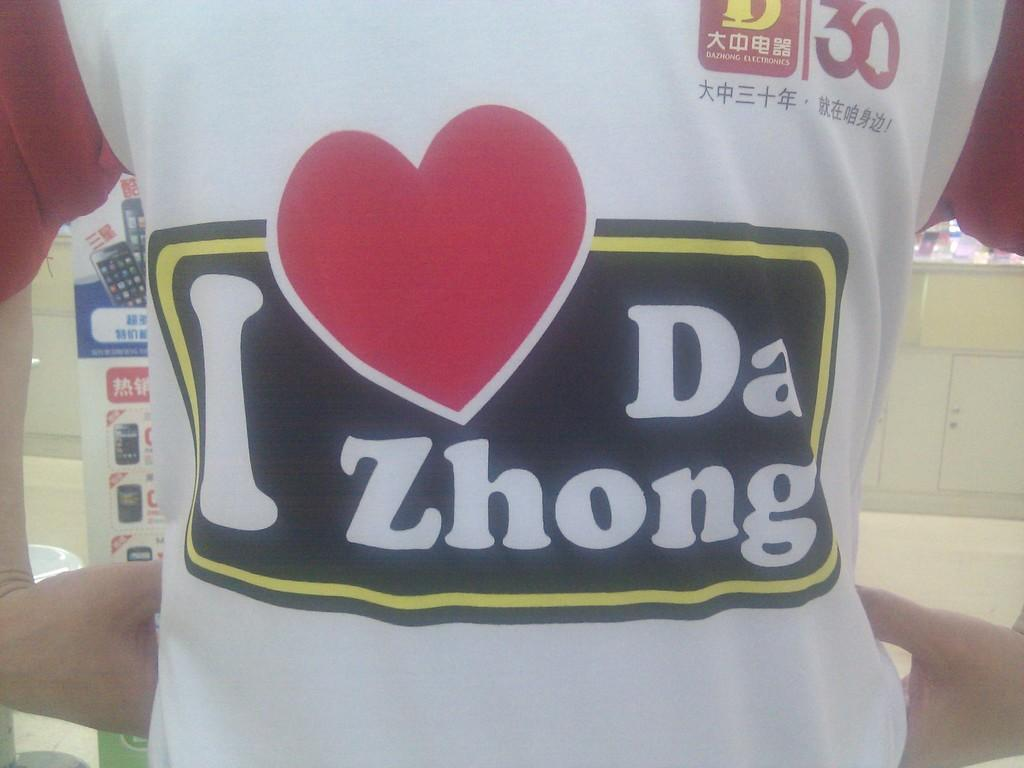Provide a one-sentence caption for the provided image. A person is wearing an I heart Da Zhong t-shirt. 